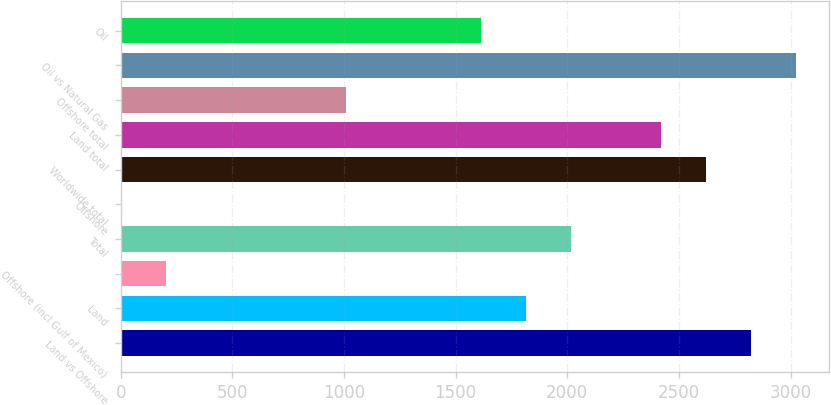Convert chart. <chart><loc_0><loc_0><loc_500><loc_500><bar_chart><fcel>Land vs Offshore<fcel>Land<fcel>Offshore (incl Gulf of Mexico)<fcel>Total<fcel>Offshore<fcel>Worldwide total<fcel>Land total<fcel>Offshore total<fcel>Oil vs Natural Gas<fcel>Oil<nl><fcel>2821.6<fcel>1814.6<fcel>203.4<fcel>2016<fcel>2<fcel>2620.2<fcel>2418.8<fcel>1009<fcel>3023<fcel>1613.2<nl></chart> 